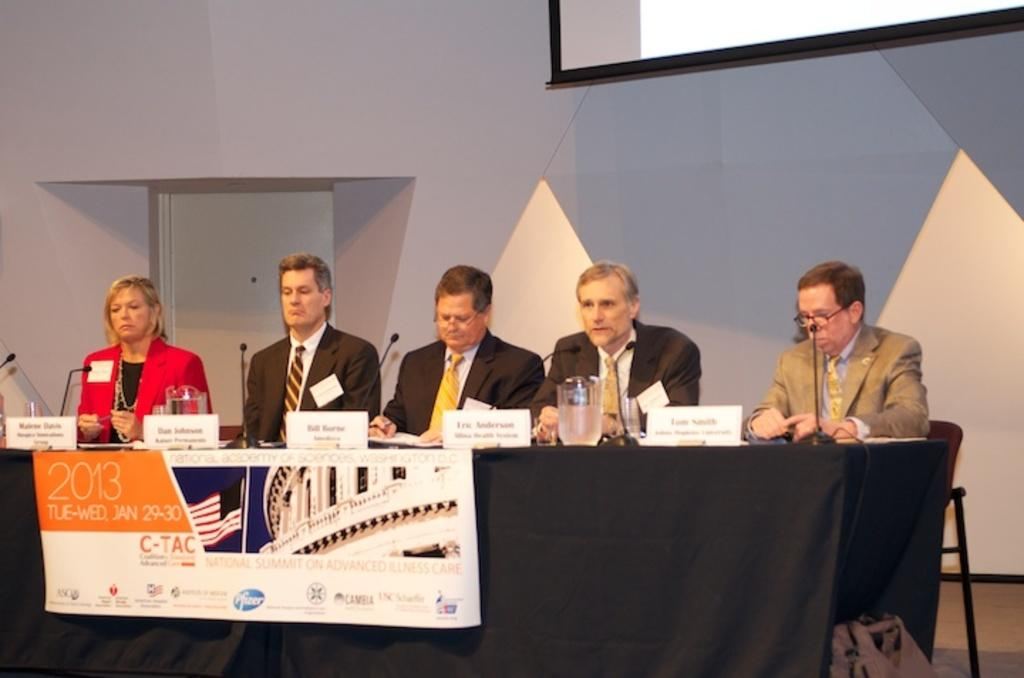What is the main object in the image? There is a table in the image. What items are placed on the table? There are microphones, glasses, and name boards on the table. How many people are present near the table? There are 5 persons sitting near the table. What type of story is being told by the kitten in the image? There is no kitten present in the image, so no story can be told by a kitten. 